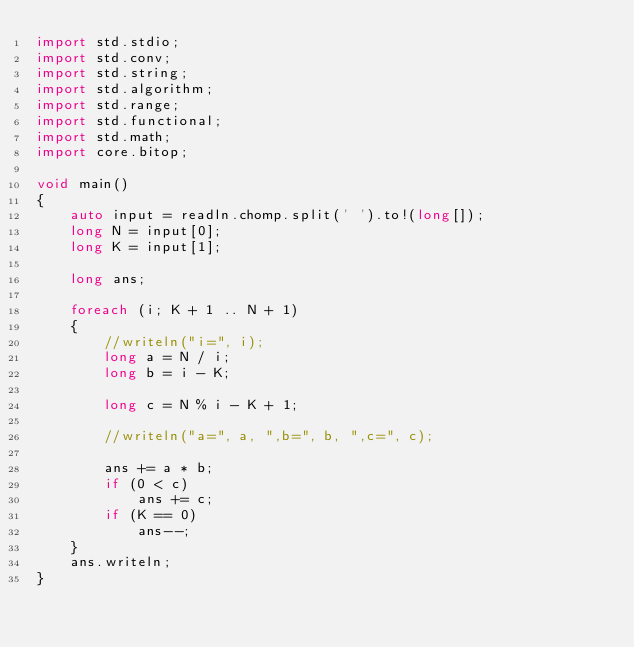Convert code to text. <code><loc_0><loc_0><loc_500><loc_500><_D_>import std.stdio;
import std.conv;
import std.string;
import std.algorithm;
import std.range;
import std.functional;
import std.math;
import core.bitop;

void main()
{
    auto input = readln.chomp.split(' ').to!(long[]);
    long N = input[0];
    long K = input[1];

    long ans;

    foreach (i; K + 1 .. N + 1)
    {
        //writeln("i=", i);
        long a = N / i;
        long b = i - K;

        long c = N % i - K + 1;

        //writeln("a=", a, ",b=", b, ",c=", c);

        ans += a * b;
        if (0 < c)
            ans += c;
        if (K == 0)
            ans--;
    }
    ans.writeln;
}
</code> 